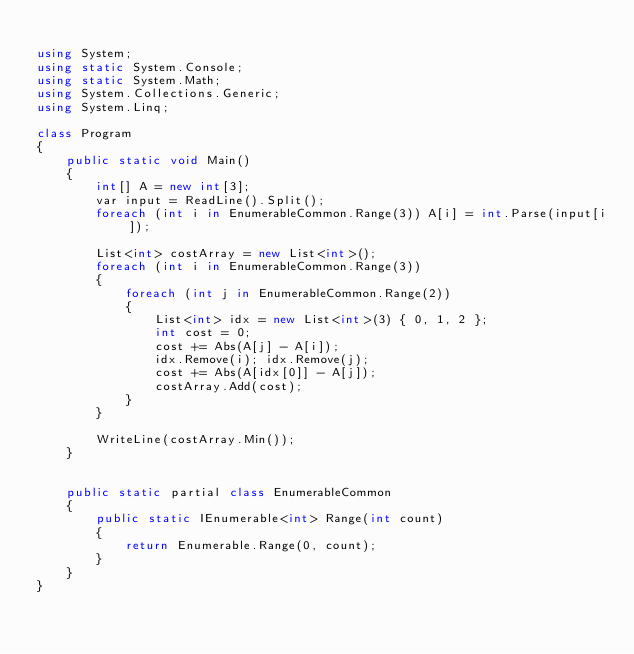<code> <loc_0><loc_0><loc_500><loc_500><_C#_>
using System;
using static System.Console;
using static System.Math;
using System.Collections.Generic;
using System.Linq;

class Program
{
    public static void Main()
    {
        int[] A = new int[3];
        var input = ReadLine().Split();
        foreach (int i in EnumerableCommon.Range(3)) A[i] = int.Parse(input[i]);

        List<int> costArray = new List<int>();
        foreach (int i in EnumerableCommon.Range(3))
        {
            foreach (int j in EnumerableCommon.Range(2))
            {
                List<int> idx = new List<int>(3) { 0, 1, 2 };
                int cost = 0;
                cost += Abs(A[j] - A[i]);
                idx.Remove(i); idx.Remove(j);
                cost += Abs(A[idx[0]] - A[j]);
                costArray.Add(cost);
            }
        }

        WriteLine(costArray.Min());
    }


    public static partial class EnumerableCommon
    {
        public static IEnumerable<int> Range(int count)
        {
            return Enumerable.Range(0, count);
        }
    }
}
</code> 